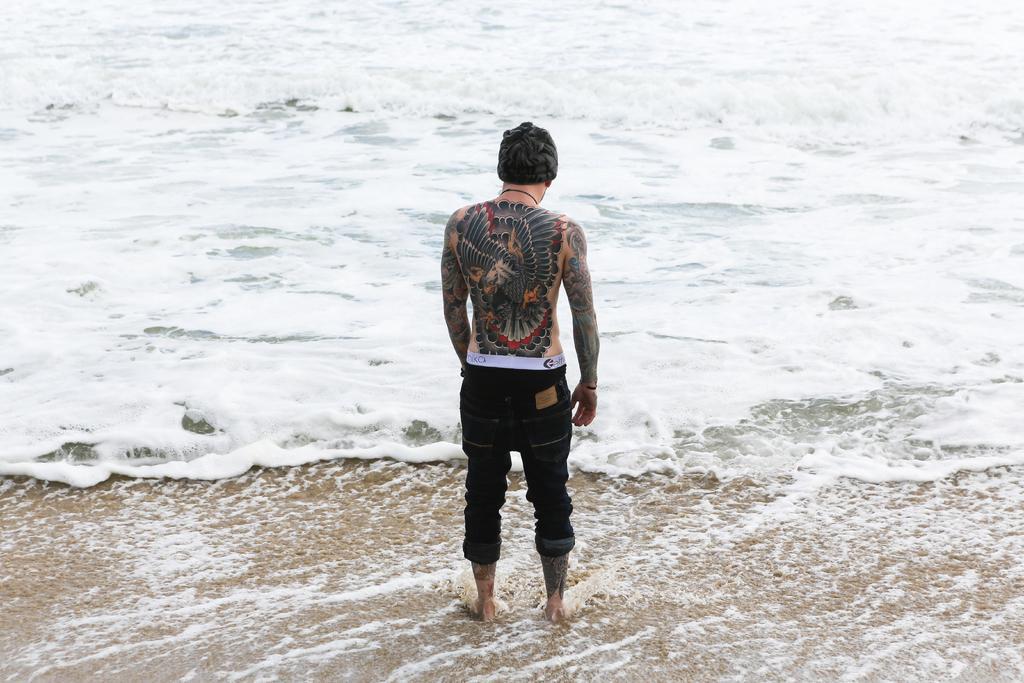Can you describe this image briefly? In this picture we can see we can see some tattoos visible on the body of a person. This person is standing. We can see waves in the water. 